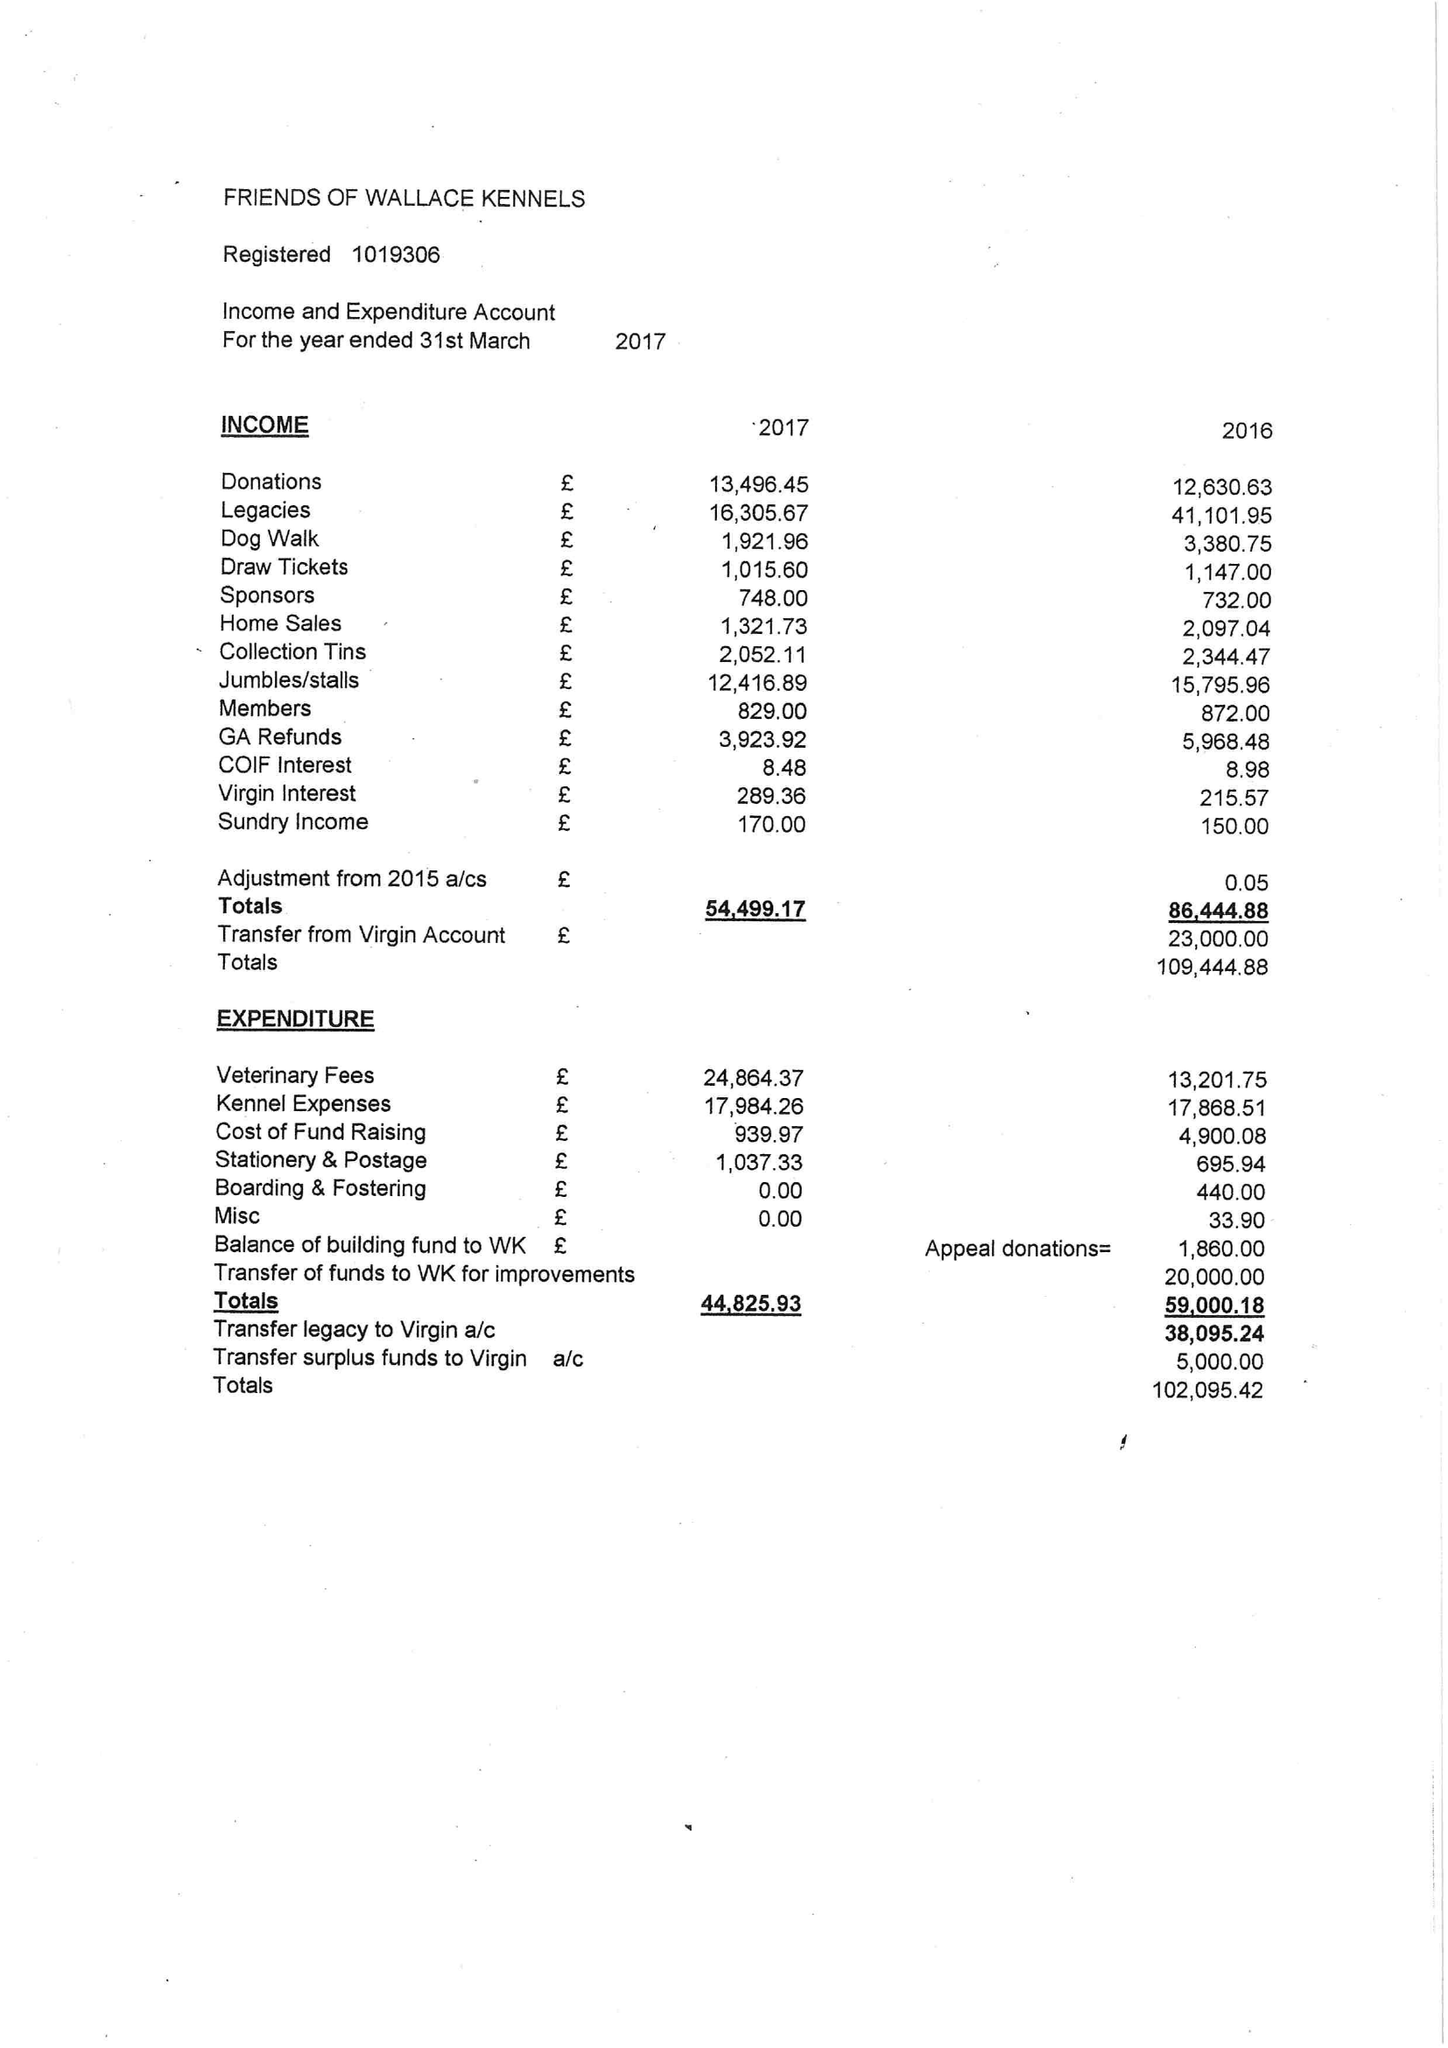What is the value for the address__postcode?
Answer the question using a single word or phrase. CM11 1JD 